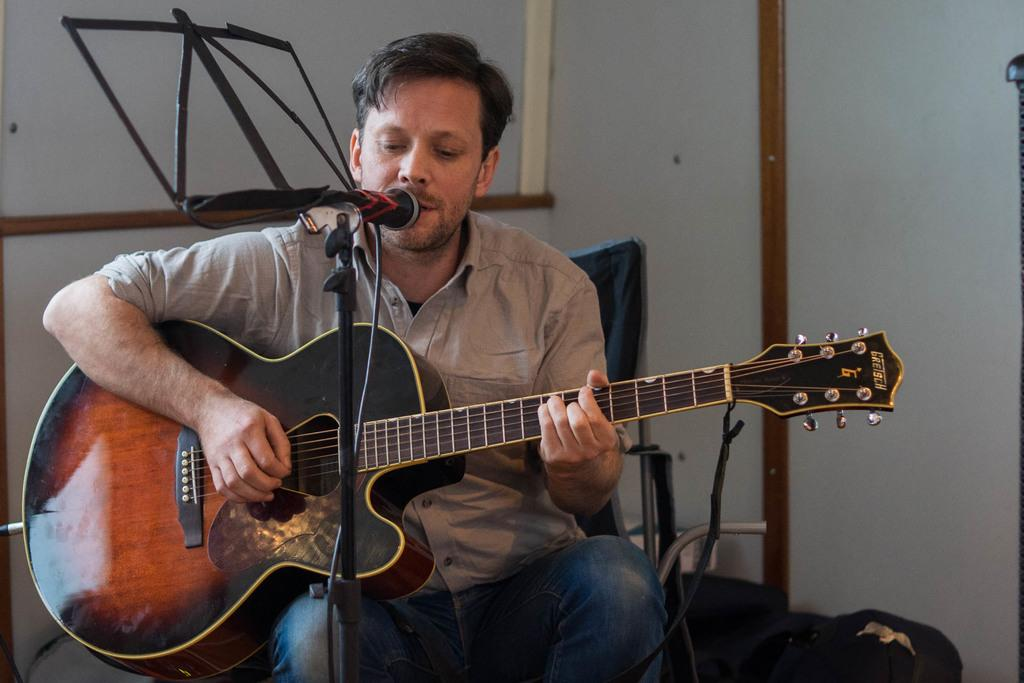What is the person in the image doing? The person is sitting on a chair, playing a guitar, singing a song, and using a microphone. Can you describe the person's activity in more detail? The person is playing a guitar and singing a song, which suggests they might be performing for an audience. What object is the person using to amplify their voice? The person is using a microphone to amplify their voice. What type of crown is the person wearing in the image? There is no crown present in the image; the person is only wearing a microphone while playing the guitar and singing. 